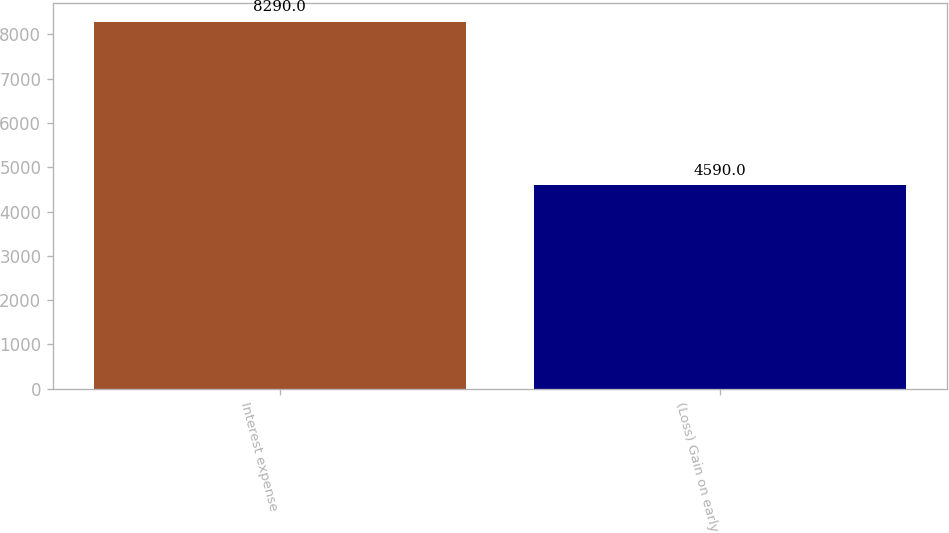Convert chart. <chart><loc_0><loc_0><loc_500><loc_500><bar_chart><fcel>Interest expense<fcel>(Loss) Gain on early<nl><fcel>8290<fcel>4590<nl></chart> 